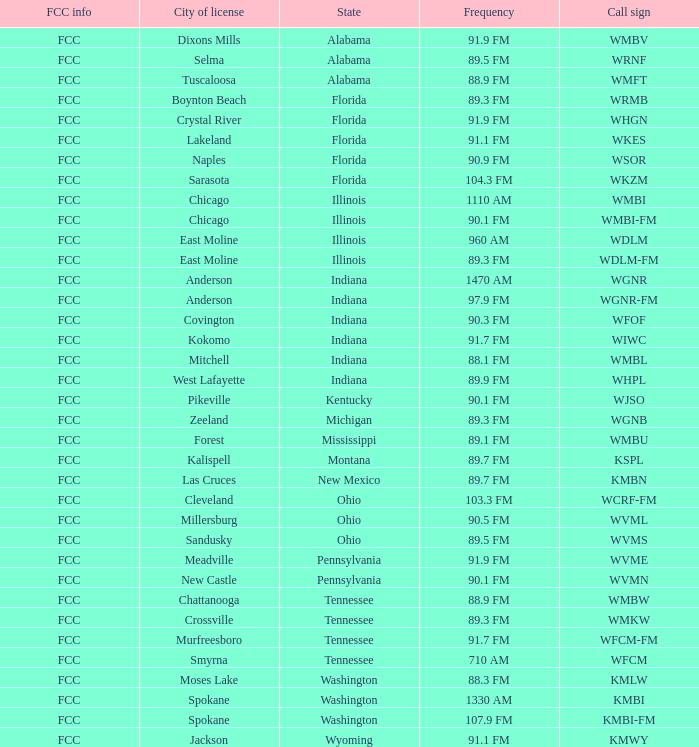What is the frequency of the radio station in Indiana that has a call sign of WGNR? 1470 AM. 